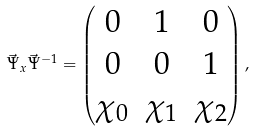Convert formula to latex. <formula><loc_0><loc_0><loc_500><loc_500>\vec { \Psi } _ { x } \vec { \Psi } ^ { - 1 } = \begin{pmatrix} 0 & 1 & 0 \\ 0 & 0 & 1 \\ \chi _ { 0 } & \chi _ { 1 } & \chi _ { 2 } \end{pmatrix} ,</formula> 